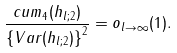Convert formula to latex. <formula><loc_0><loc_0><loc_500><loc_500>\frac { c u m _ { 4 } ( h _ { l ; 2 } ) } { \left \{ V a r ( h _ { l ; 2 } ) \right \} ^ { 2 } } = o _ { l \rightarrow \infty } ( 1 ) .</formula> 